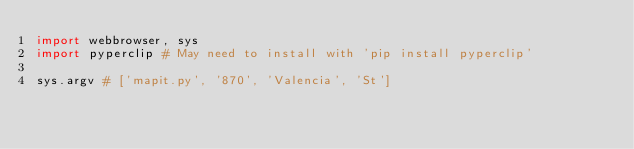<code> <loc_0><loc_0><loc_500><loc_500><_Python_>import webbrowser, sys
import pyperclip # May need to install with 'pip install pyperclip'

sys.argv # ['mapit.py', '870', 'Valencia', 'St']
</code> 